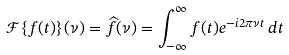<formula> <loc_0><loc_0><loc_500><loc_500>\mathcal { F } \left \{ f ( t ) \right \} ( \nu ) = \widehat { f } ( \nu ) = \int _ { - \infty } ^ { \infty } f ( t ) e ^ { - i 2 \pi \nu t } \, d t</formula> 